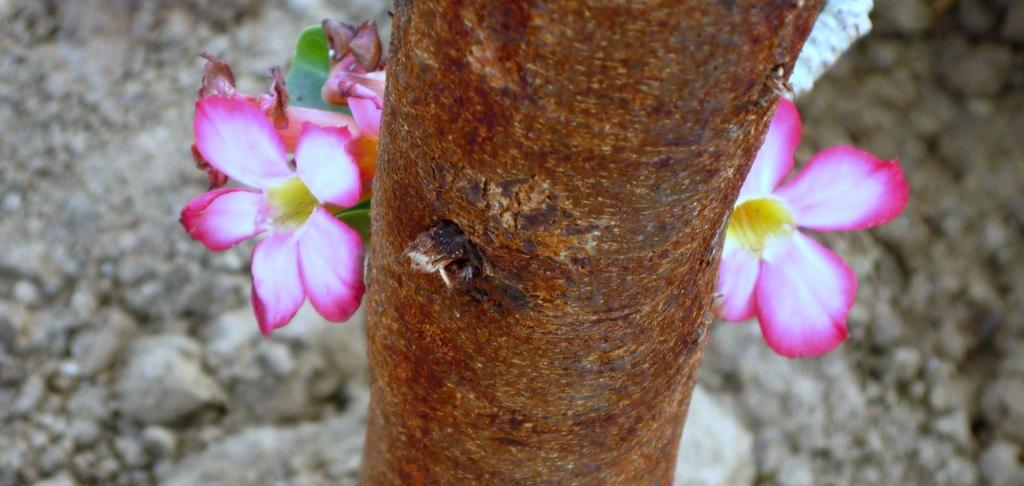What is the main subject in the center of the image? There is a tree in the center of the image. What can be seen on the tree? There are flowers and leaves on the tree. What type of grain can be seen growing on the hill in the image? There is no hill or grain present in the image; it features a tree with flowers and leaves. 